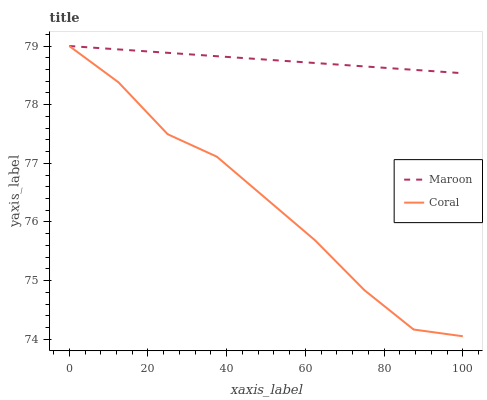Does Maroon have the minimum area under the curve?
Answer yes or no. No. Is Maroon the roughest?
Answer yes or no. No. Does Maroon have the lowest value?
Answer yes or no. No. 